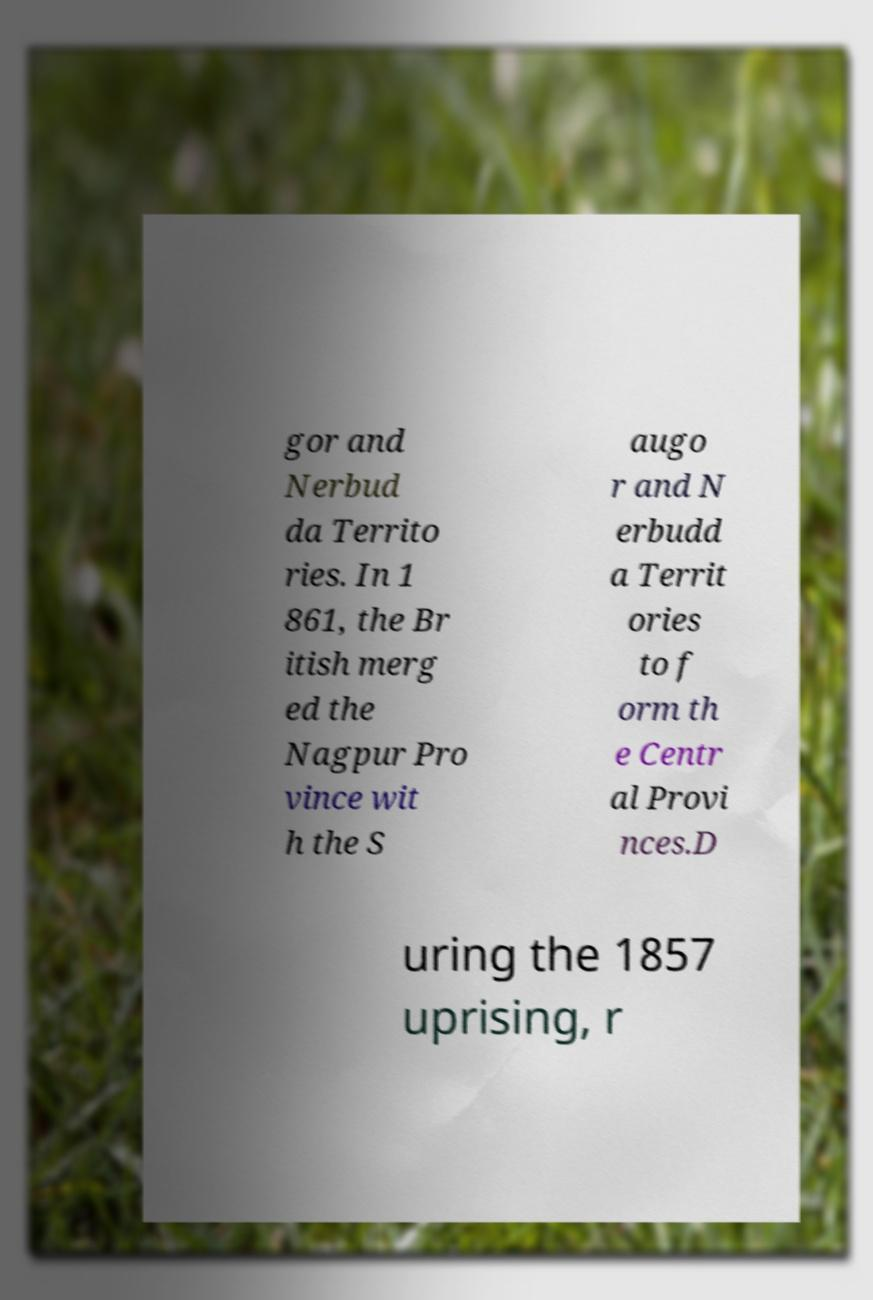There's text embedded in this image that I need extracted. Can you transcribe it verbatim? gor and Nerbud da Territo ries. In 1 861, the Br itish merg ed the Nagpur Pro vince wit h the S augo r and N erbudd a Territ ories to f orm th e Centr al Provi nces.D uring the 1857 uprising, r 